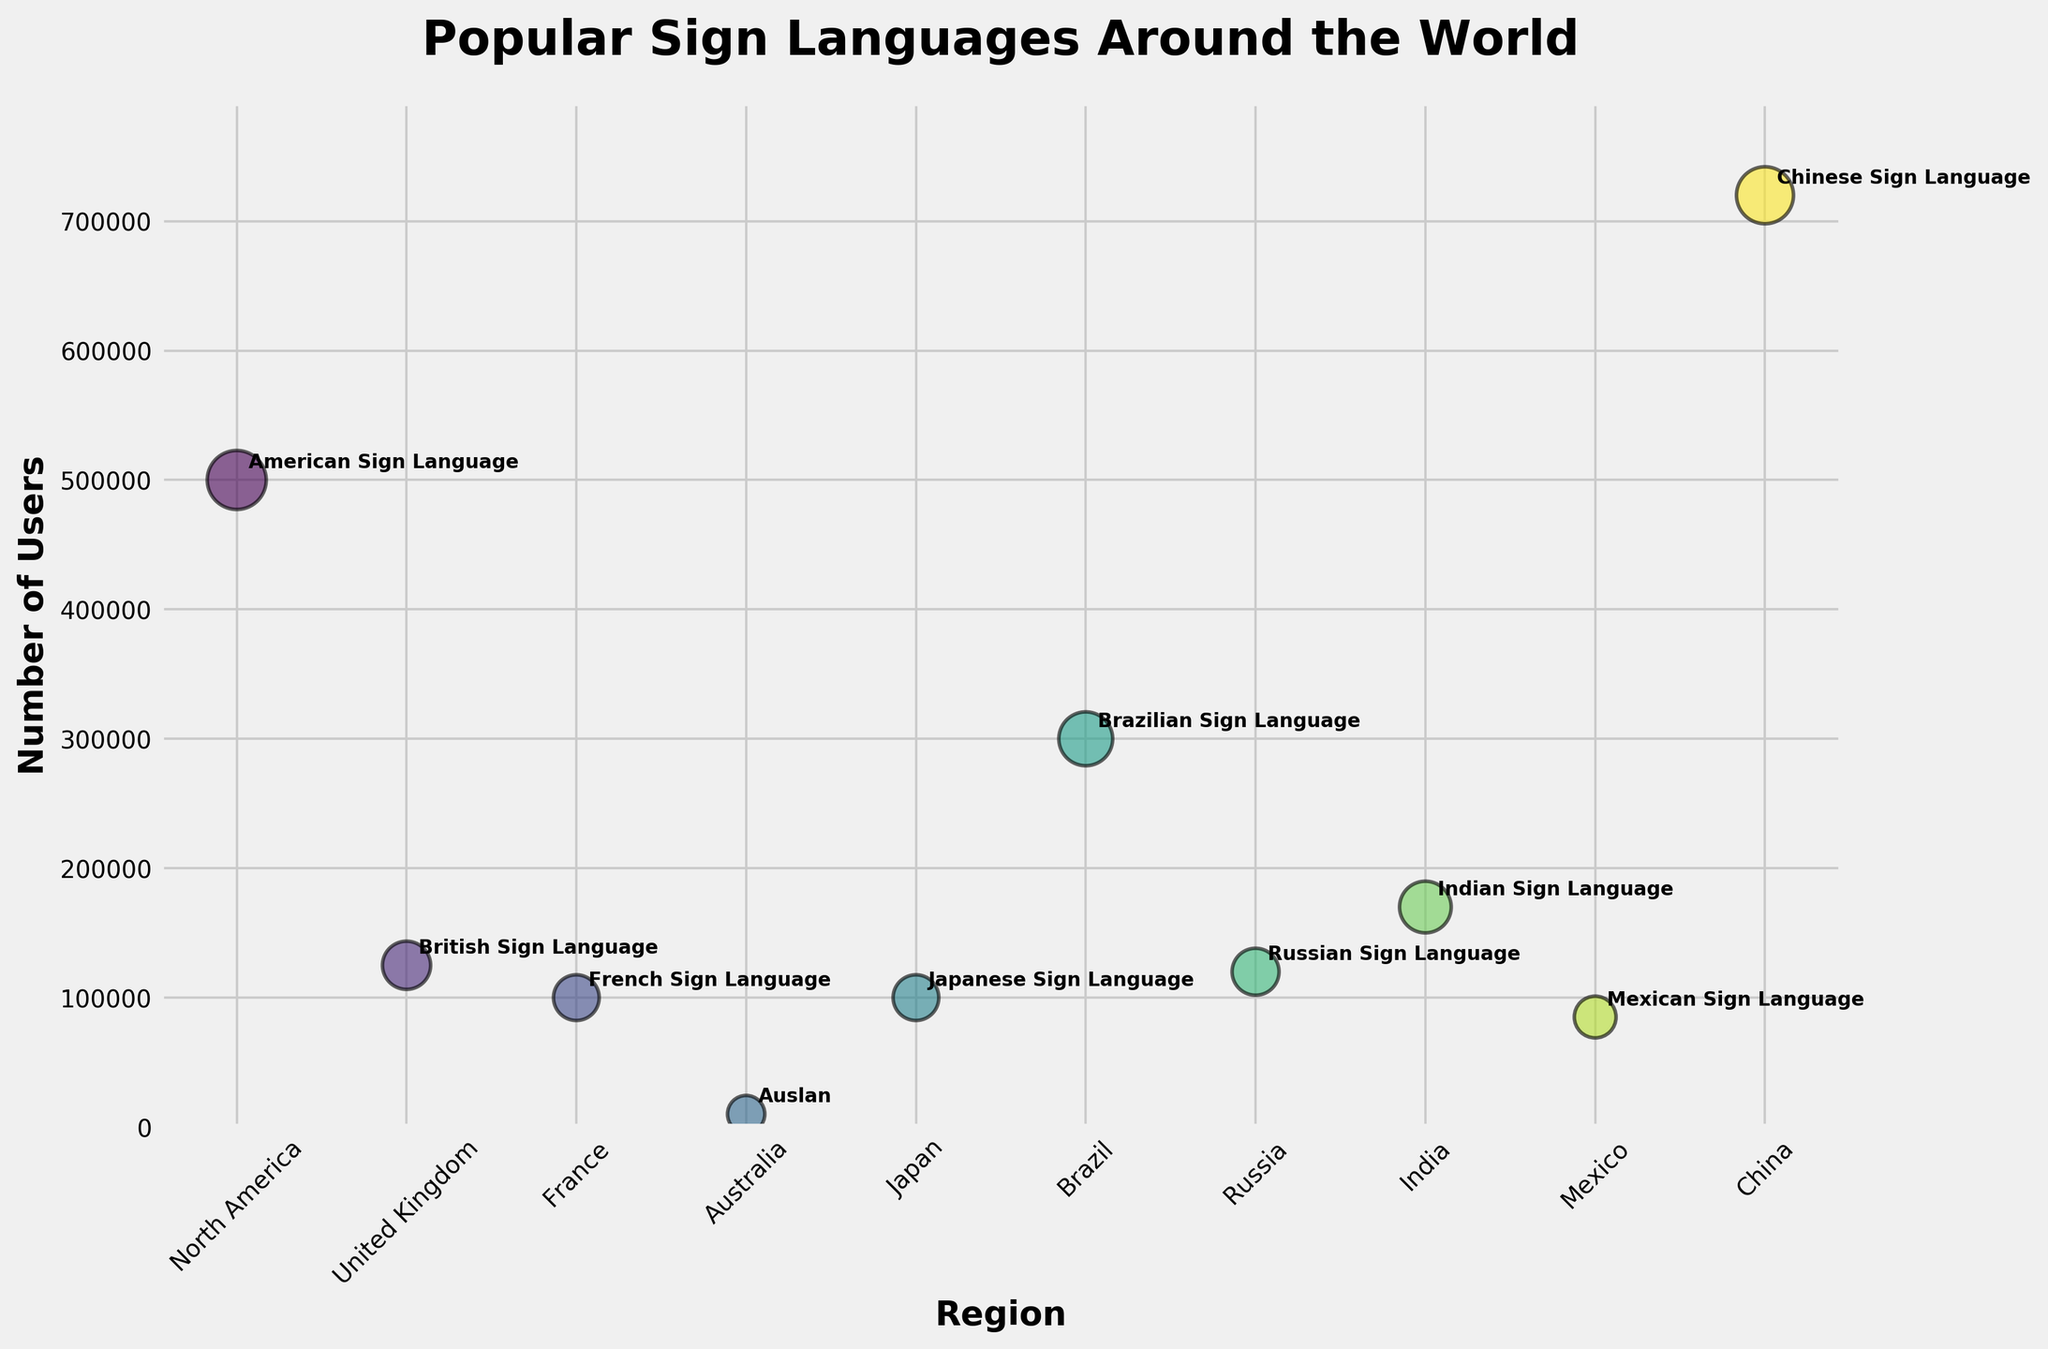What's the title of the plot? The title is located at the top of the plot and usually summarizes the main point or content of the plot.
Answer: Popular Sign Languages Around the World How many sign languages are depicted in the plot? To determine the number of sign languages, we count the individual data points (bubbles) in the plot.
Answer: 10 Which region has the largest bubble and what is its size? Each bubble in the plot represents a sign language, and the size is proportional to the number of users. The largest bubble will be the one associated with Chinese Sign Language in China.
Answer: China, 28 What is the region with the fewest number of users for their sign language? By looking at the vertical position of the bubbles, which indicates the number of users, we can see that the lowest one corresponds to Auslan in Australia.
Answer: Australia How many sign languages have a user count of 100,000 or more? Observing the vertical axis and the bubbles above the 100,000 line, count the bubbles.
Answer: 6 What's the difference in the number of users between Brazilian Sign Language and British Sign Language? Subtract the number of users of British Sign Language from the number of users of Brazilian Sign Language (300,000 - 125,000).
Answer: 175,000 Which sign language has the second highest number of users? By looking at the height of the bubbles and comparing them, the second highest after Chinese Sign Language (720,000) is American Sign Language (500,000).
Answer: American Sign Language Which region has the smallest bubble? The smallest bubble size corresponds to the smallest radius in the plot, which is for Auslan in Australia.
Answer: Australia Compare the number of users of Mexican Sign Language to French Sign Language. Which one has more users and by how much? Mexican Sign Language has 85,000 users and French Sign Language has 100,000 users. Subtract the smaller from the larger.
Answer: French Sign Language, 15,000 If we average the number of users for Indian Sign Language and Russian Sign Language, what is the result? Add the users of Indian Sign Language (170,000) and Russian Sign Language (120,000) and divide by 2.
Answer: 145,000 